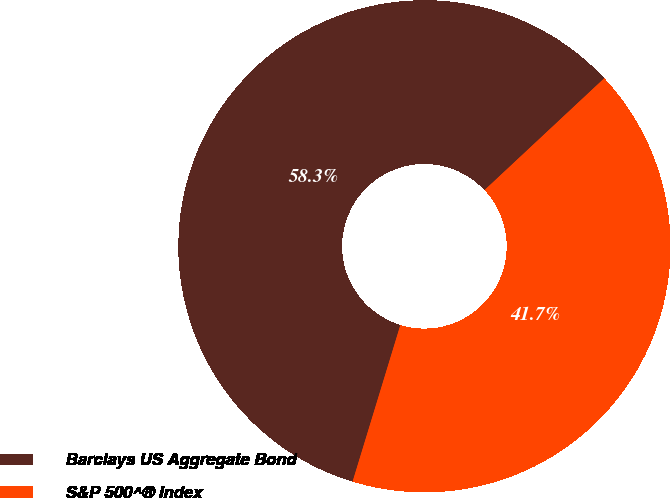<chart> <loc_0><loc_0><loc_500><loc_500><pie_chart><fcel>Barclays US Aggregate Bond<fcel>S&P 500^® Index<nl><fcel>58.33%<fcel>41.67%<nl></chart> 